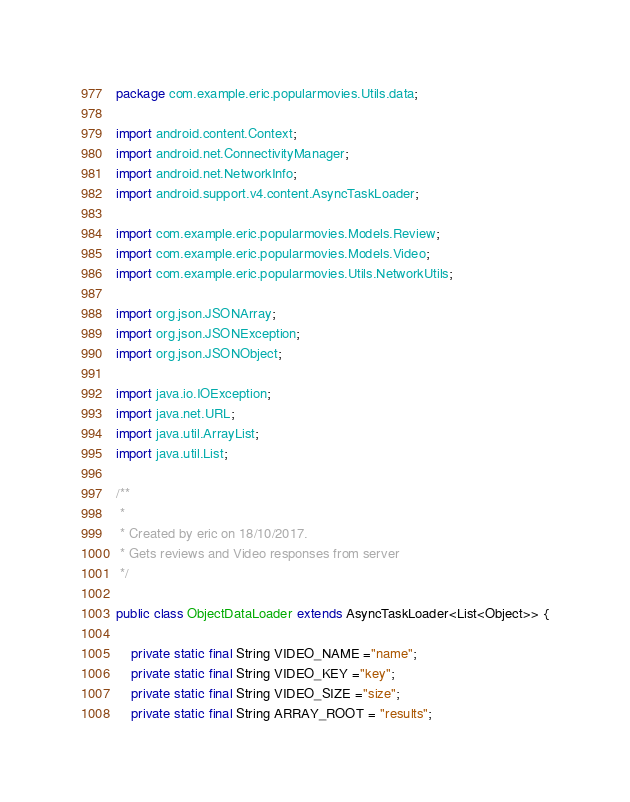<code> <loc_0><loc_0><loc_500><loc_500><_Java_>package com.example.eric.popularmovies.Utils.data;

import android.content.Context;
import android.net.ConnectivityManager;
import android.net.NetworkInfo;
import android.support.v4.content.AsyncTaskLoader;

import com.example.eric.popularmovies.Models.Review;
import com.example.eric.popularmovies.Models.Video;
import com.example.eric.popularmovies.Utils.NetworkUtils;

import org.json.JSONArray;
import org.json.JSONException;
import org.json.JSONObject;

import java.io.IOException;
import java.net.URL;
import java.util.ArrayList;
import java.util.List;

/**
 *
 * Created by eric on 18/10/2017.
 * Gets reviews and Video responses from server
 */

public class ObjectDataLoader extends AsyncTaskLoader<List<Object>> {

    private static final String VIDEO_NAME ="name";
    private static final String VIDEO_KEY ="key";
    private static final String VIDEO_SIZE ="size";
    private static final String ARRAY_ROOT = "results";
</code> 